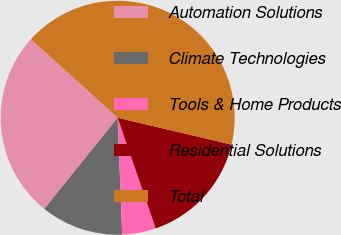Convert chart to OTSL. <chart><loc_0><loc_0><loc_500><loc_500><pie_chart><fcel>Automation Solutions<fcel>Climate Technologies<fcel>Tools & Home Products<fcel>Residential Solutions<fcel>Total<nl><fcel>25.94%<fcel>11.4%<fcel>4.65%<fcel>16.05%<fcel>41.96%<nl></chart> 